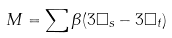Convert formula to latex. <formula><loc_0><loc_0><loc_500><loc_500>M = \sum \beta ( 3 \Box _ { s } - 3 \Box _ { t } )</formula> 